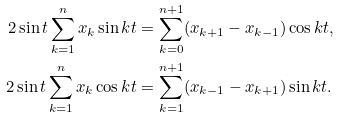<formula> <loc_0><loc_0><loc_500><loc_500>2 \sin t \sum _ { k = 1 } ^ { n } x _ { k } \sin k t & = \sum _ { k = 0 } ^ { n + 1 } ( x _ { k + 1 } - x _ { k - 1 } ) \cos k t , \\ 2 \sin t \sum _ { k = 1 } ^ { n } x _ { k } \cos k t & = \sum _ { k = 1 } ^ { n + 1 } ( x _ { k - 1 } - x _ { k + 1 } ) \sin k t .</formula> 